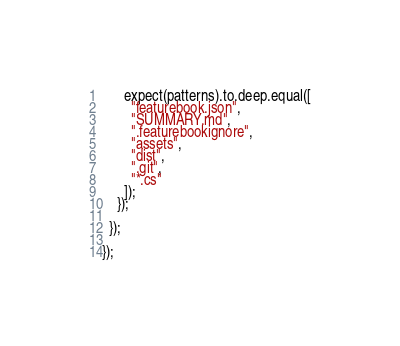Convert code to text. <code><loc_0><loc_0><loc_500><loc_500><_JavaScript_>      expect(patterns).to.deep.equal([
        "featurebook.json",
        "SUMMARY.md",
        ".featurebookignore",
        "assets",
        "dist",
        ".git",
        "*.cs"
      ]);
    });

  });

});
</code> 